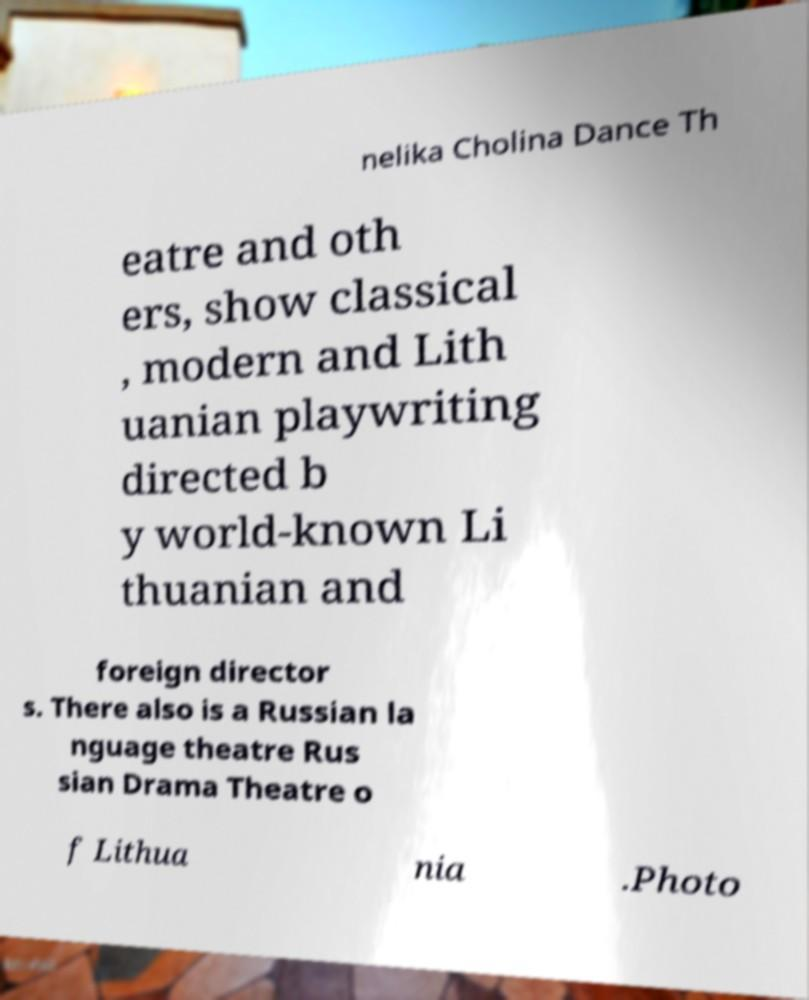Can you read and provide the text displayed in the image?This photo seems to have some interesting text. Can you extract and type it out for me? nelika Cholina Dance Th eatre and oth ers, show classical , modern and Lith uanian playwriting directed b y world-known Li thuanian and foreign director s. There also is a Russian la nguage theatre Rus sian Drama Theatre o f Lithua nia .Photo 